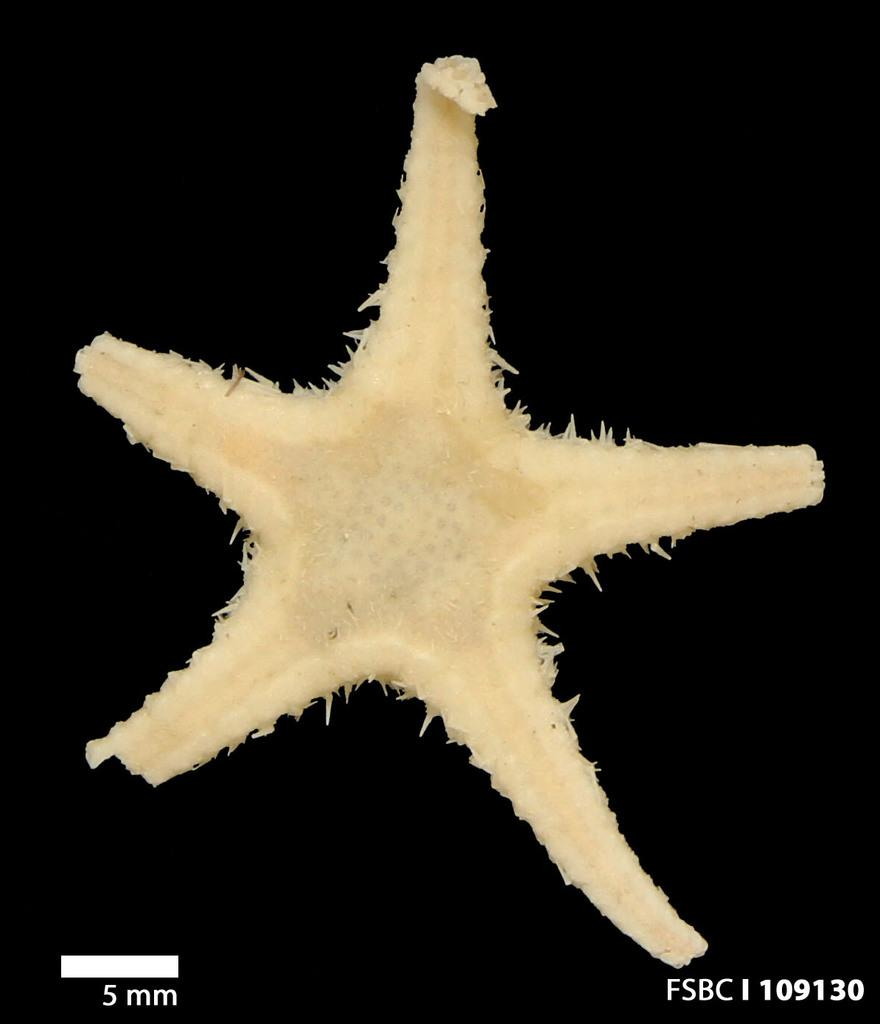What is the color of the background in the image? The background of the image is dark. What is the main subject in the middle of the image? There is a starfish in the middle of the image. What can be found at the bottom of the image? There is text at the bottom of the image. What type of temper does the starfish have in the image? There is no indication of the starfish's temper in the image, as it is an inanimate object. 